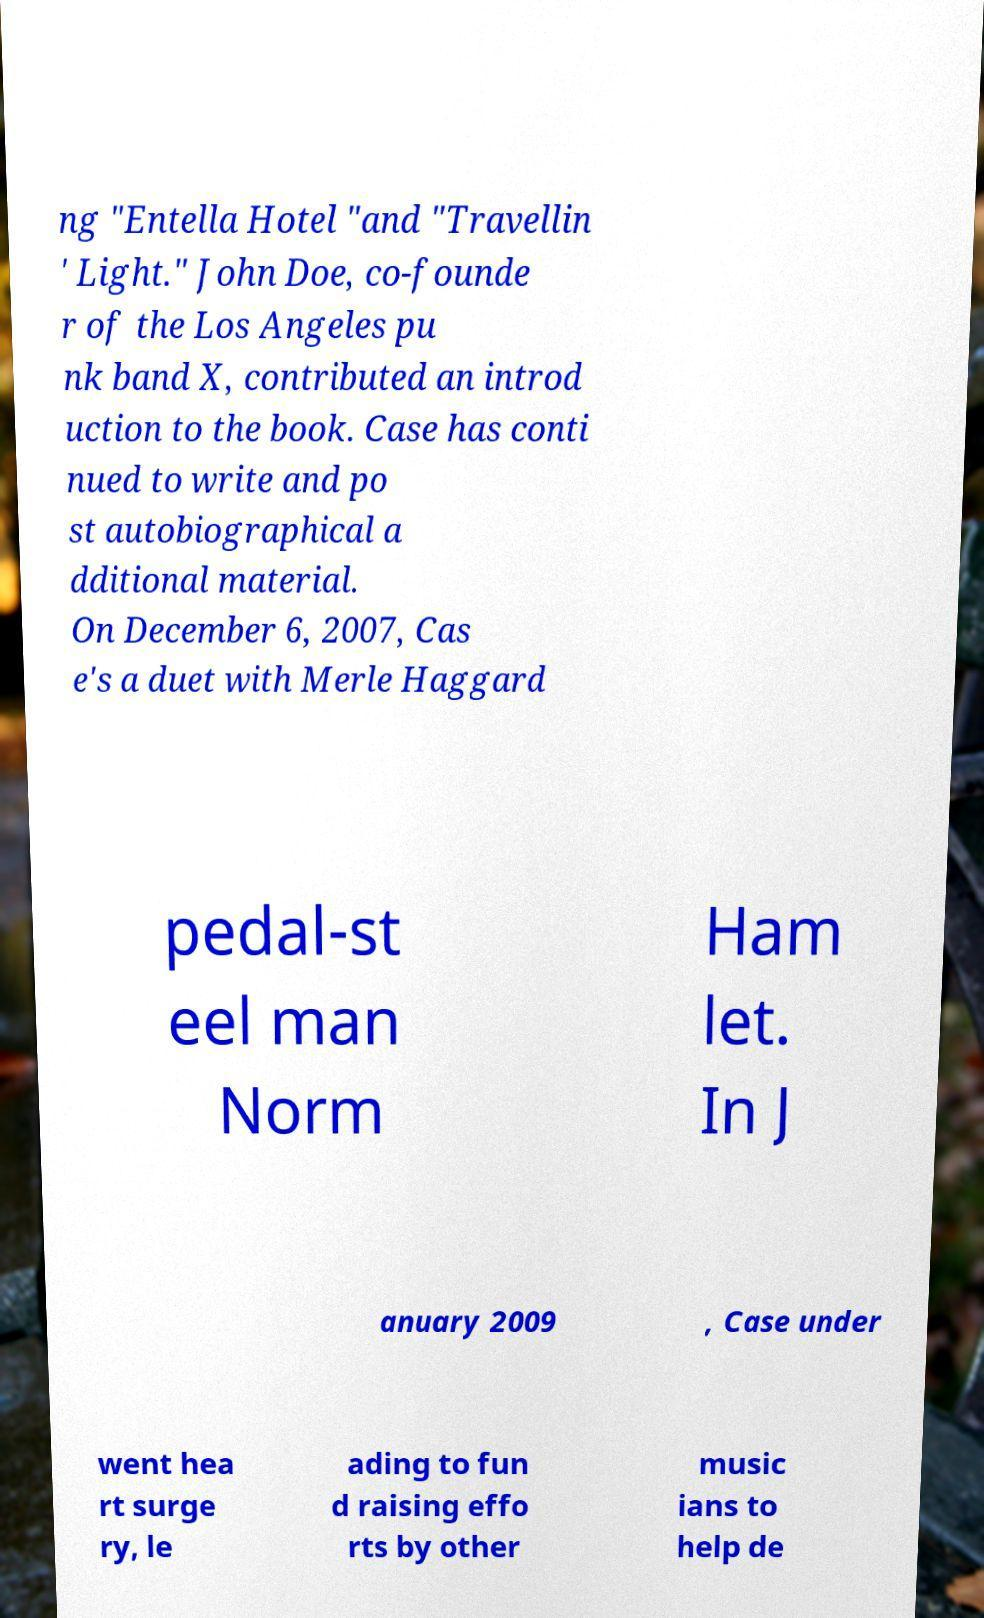Please identify and transcribe the text found in this image. ng "Entella Hotel "and "Travellin ' Light." John Doe, co-founde r of the Los Angeles pu nk band X, contributed an introd uction to the book. Case has conti nued to write and po st autobiographical a dditional material. On December 6, 2007, Cas e's a duet with Merle Haggard pedal-st eel man Norm Ham let. In J anuary 2009 , Case under went hea rt surge ry, le ading to fun d raising effo rts by other music ians to help de 